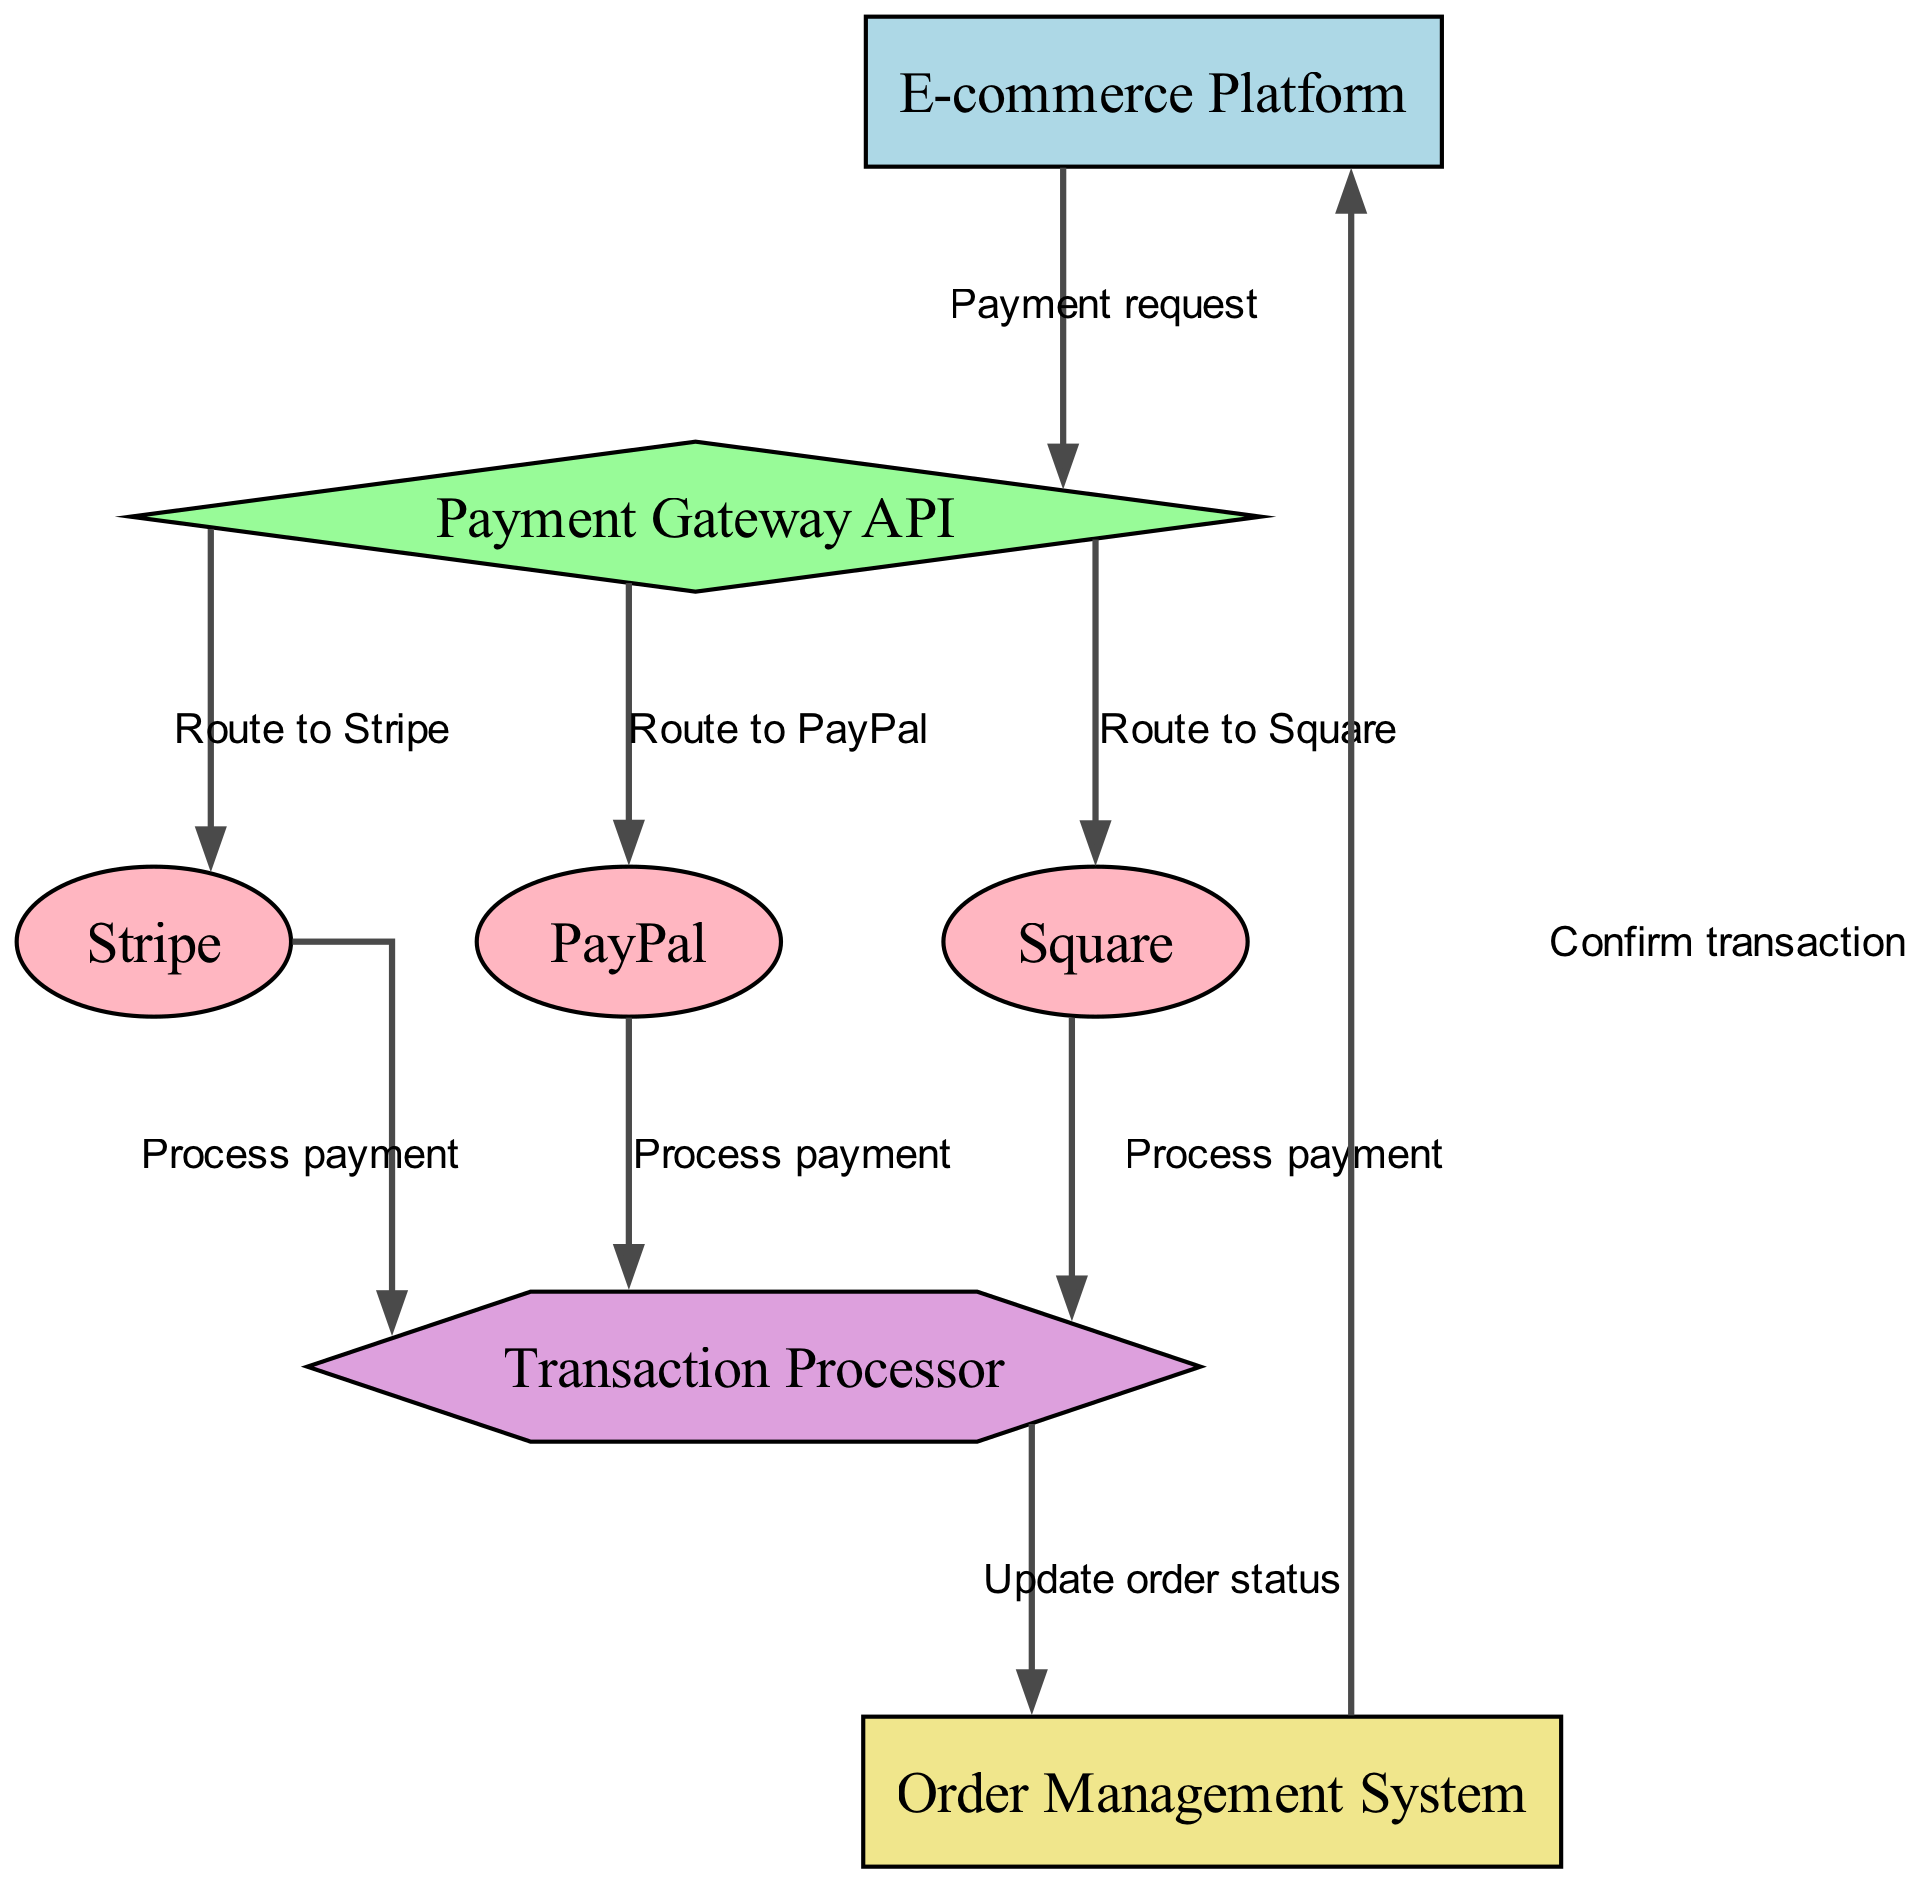What is the total number of nodes in the diagram? The diagram lists a total of 7 distinct nodes: E-commerce Platform, Payment Gateway API, Stripe, PayPal, Square, Transaction Processor, and Order Management System.
Answer: 7 What type of node is the Payment Gateway API? The Payment Gateway API is depicted as a diamond shape in the diagram, which indicates that it plays a pivotal role in routing payment requests.
Answer: diamond Which payment providers are routed through the Payment Gateway API? The diagram indicates that the Payment Gateway API routes to three payment providers: Stripe, PayPal, and Square, as represented by directed edges leading to these nodes.
Answer: Stripe, PayPal, Square What is the final action in the data flow after processing a payment? The final action in the data flow is to confirm the transaction by sending a message from the Order Management System back to the E-commerce Platform.
Answer: Confirm transaction How many payment processing routes are depicted in the diagram? The diagram shows three distinct routes from the Payment Gateway API to the payment processors: one for Stripe, one for PayPal, and one for Square, leading to a total of three payment processing routes.
Answer: 3 What does the Transaction Processor do after receiving payment from a provider? The Transaction Processor updates the order status after processing the payment, as indicated by the edge leading from Transaction Processor to Order Management System in the diagram.
Answer: Update order status Which node sends the initial payment request? The initial payment request is sent by the E-commerce Platform to the Payment Gateway API, indicating where the process begins in the diagram.
Answer: E-commerce Platform In what shape is the Transaction Processor represented? The Transaction Processor is depicted as a hexagon in the diagram, which signifies its role in handling and processing transactions received from the payment providers.
Answer: hexagon Which payment provider is not shown in the edge leading to the Transaction Processor? The diagram illustrates that all three payment providers (Stripe, PayPal, and Square) route to the Transaction Processor, but there are no other payment providers represented, indicating no others are included.
Answer: None 